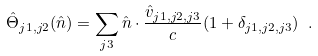Convert formula to latex. <formula><loc_0><loc_0><loc_500><loc_500>\hat { \Theta } _ { j 1 , j 2 } ( \hat { n } ) = \sum _ { j 3 } { \hat { n } } \cdot \frac { \hat { v } _ { j 1 , j 2 , j 3 } } { c } ( 1 + \delta _ { j 1 , j 2 , j 3 } ) \ .</formula> 